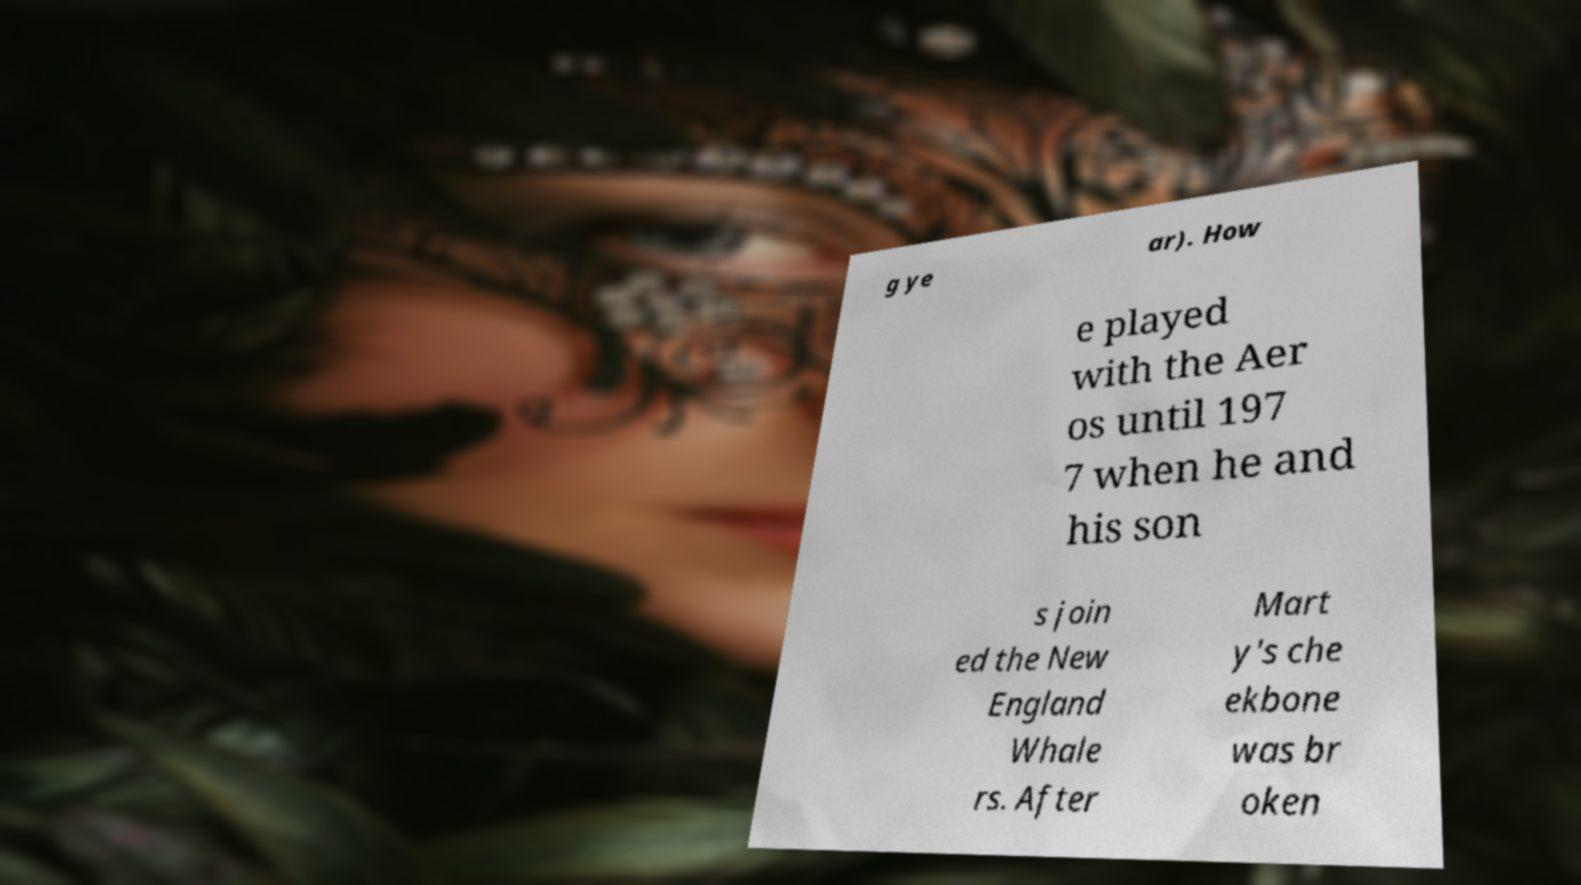Could you extract and type out the text from this image? g ye ar). How e played with the Aer os until 197 7 when he and his son s join ed the New England Whale rs. After Mart y's che ekbone was br oken 